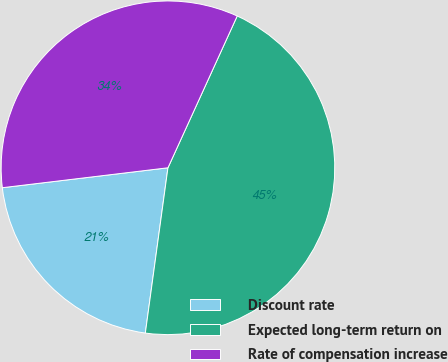Convert chart. <chart><loc_0><loc_0><loc_500><loc_500><pie_chart><fcel>Discount rate<fcel>Expected long-term return on<fcel>Rate of compensation increase<nl><fcel>20.93%<fcel>45.35%<fcel>33.72%<nl></chart> 